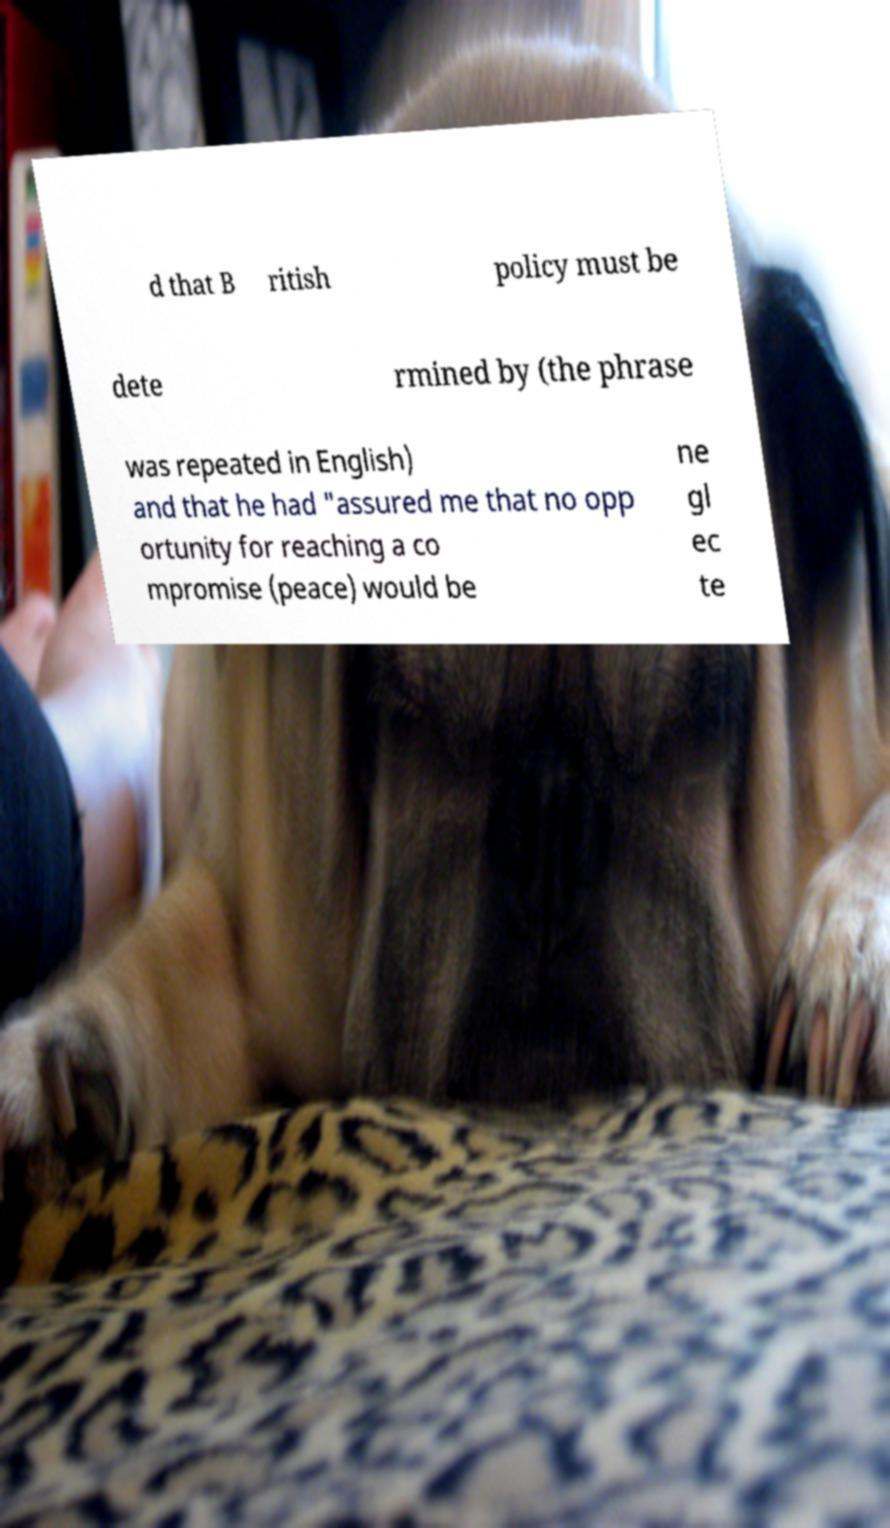What messages or text are displayed in this image? I need them in a readable, typed format. d that B ritish policy must be dete rmined by (the phrase was repeated in English) and that he had "assured me that no opp ortunity for reaching a co mpromise (peace) would be ne gl ec te 